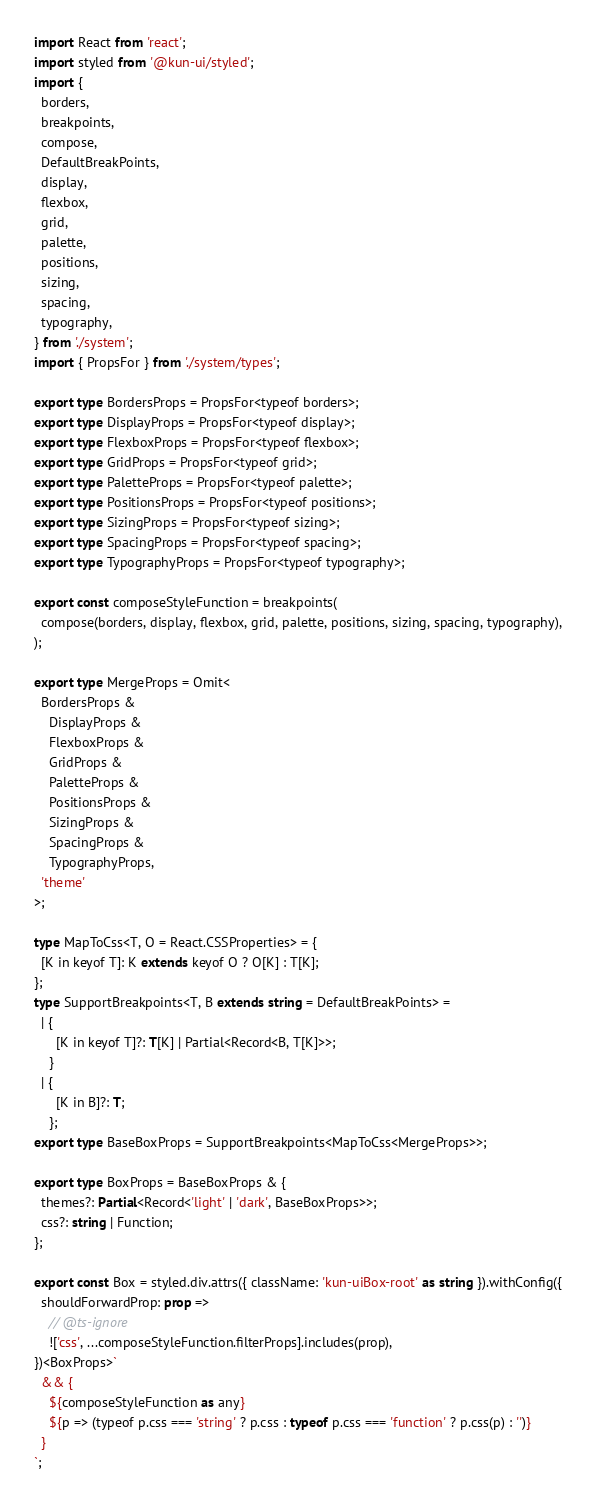Convert code to text. <code><loc_0><loc_0><loc_500><loc_500><_TypeScript_>import React from 'react';
import styled from '@kun-ui/styled';
import {
  borders,
  breakpoints,
  compose,
  DefaultBreakPoints,
  display,
  flexbox,
  grid,
  palette,
  positions,
  sizing,
  spacing,
  typography,
} from './system';
import { PropsFor } from './system/types';

export type BordersProps = PropsFor<typeof borders>;
export type DisplayProps = PropsFor<typeof display>;
export type FlexboxProps = PropsFor<typeof flexbox>;
export type GridProps = PropsFor<typeof grid>;
export type PaletteProps = PropsFor<typeof palette>;
export type PositionsProps = PropsFor<typeof positions>;
export type SizingProps = PropsFor<typeof sizing>;
export type SpacingProps = PropsFor<typeof spacing>;
export type TypographyProps = PropsFor<typeof typography>;

export const composeStyleFunction = breakpoints(
  compose(borders, display, flexbox, grid, palette, positions, sizing, spacing, typography),
);

export type MergeProps = Omit<
  BordersProps &
    DisplayProps &
    FlexboxProps &
    GridProps &
    PaletteProps &
    PositionsProps &
    SizingProps &
    SpacingProps &
    TypographyProps,
  'theme'
>;

type MapToCss<T, O = React.CSSProperties> = {
  [K in keyof T]: K extends keyof O ? O[K] : T[K];
};
type SupportBreakpoints<T, B extends string = DefaultBreakPoints> =
  | {
      [K in keyof T]?: T[K] | Partial<Record<B, T[K]>>;
    }
  | {
      [K in B]?: T;
    };
export type BaseBoxProps = SupportBreakpoints<MapToCss<MergeProps>>;

export type BoxProps = BaseBoxProps & {
  themes?: Partial<Record<'light' | 'dark', BaseBoxProps>>;
  css?: string | Function;
};

export const Box = styled.div.attrs({ className: 'kun-uiBox-root' as string }).withConfig({
  shouldForwardProp: prop =>
    // @ts-ignore
    !['css', ...composeStyleFunction.filterProps].includes(prop),
})<BoxProps>`
  && {
    ${composeStyleFunction as any}
    ${p => (typeof p.css === 'string' ? p.css : typeof p.css === 'function' ? p.css(p) : '')}
  }
`;
</code> 